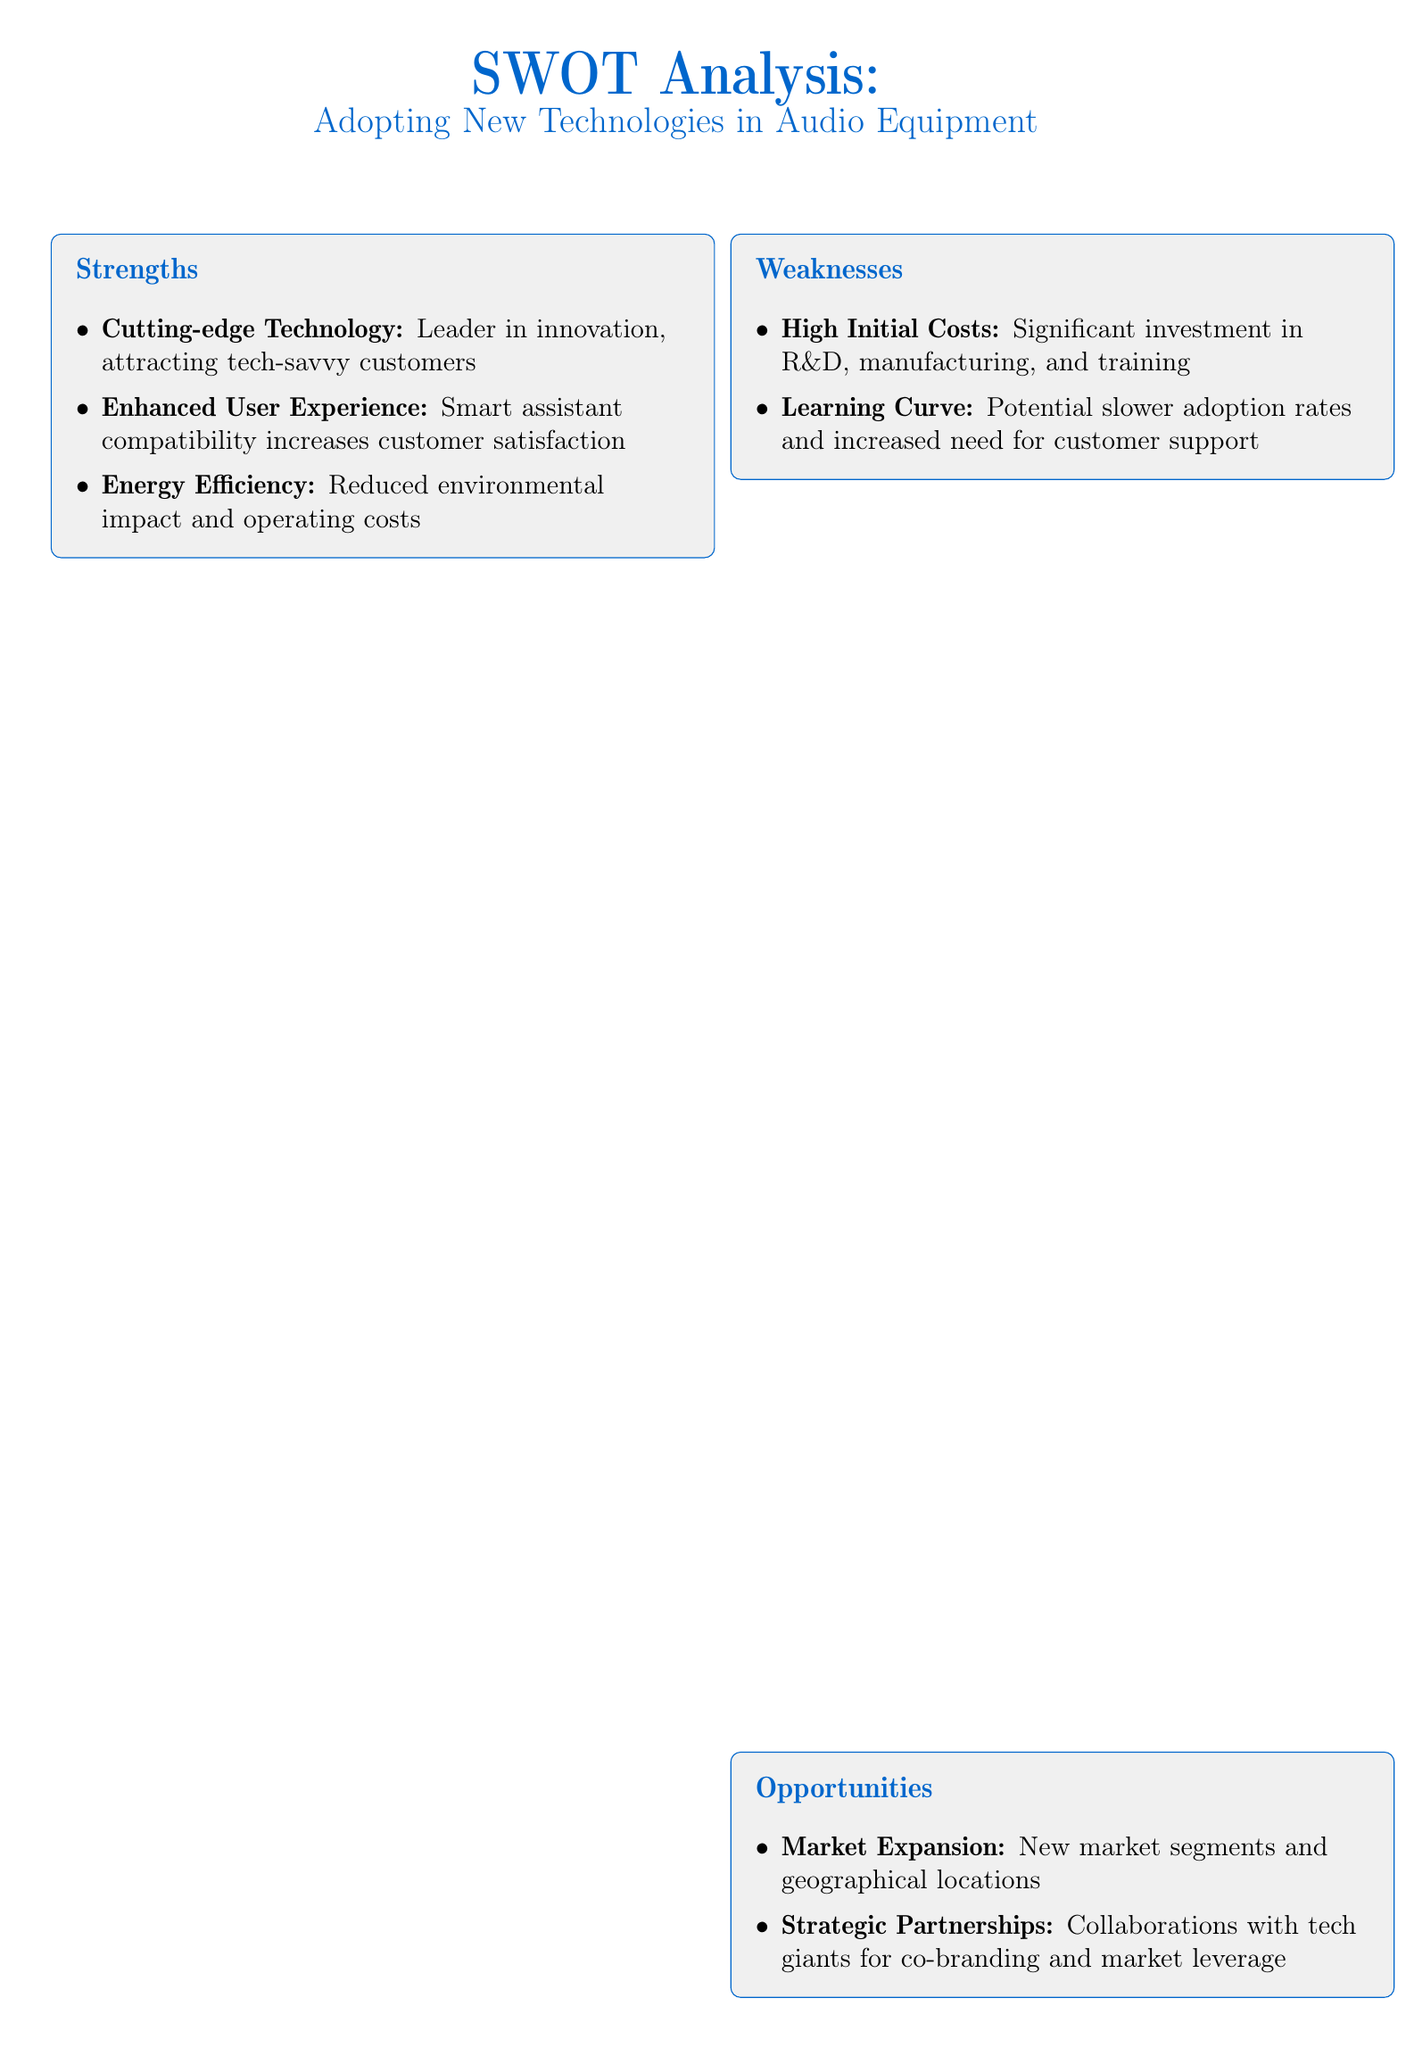What are the strengths of adopting new technologies? The strengths are listed in the document, including cutting-edge technology, enhanced user experience, and energy efficiency.
Answer: Cutting-edge technology, enhanced user experience, energy efficiency What is a weakness associated with adopting new technologies? The weakness section outlines the high initial costs and learning curve associated with new technologies.
Answer: High Initial Costs What opportunities are mentioned for market expansion? The document lists market expansion as an opportunity linked to new market segments and geographical locations.
Answer: New market segments and geographical locations What is a potential threat related to rapid technological changes? The threats section discusses the risk of product obsolescence due to rapid technological changes.
Answer: Risk of product obsolescence What investment is necessary for adopting new technologies? The weaknesses highlight the significant investment required in research, development, and manufacturing.
Answer: Significant investment in R&D What type of partnerships are suggested as an opportunity? The document mentions strategic partnerships with tech giants as a way to enhance market leverage.
Answer: Collaborations with tech giants How does enhanced user experience impact customer satisfaction? The strengths detail that smart assistant compatibility increases customer satisfaction as a part of enhanced user experience.
Answer: Increases customer satisfaction What cybersecurity concern is listed as a threat? The threats section includes the need for robust security measures to protect data as a cybersecurity risk.
Answer: Need for robust security measures Which industry aspect faces competitive pressure? The threats mention challenges from established brands in maintaining market share as a key issue for the industry.
Answer: Maintaining market share What does the conclusion emphasize about adopting new technologies? The conclusion summarizes that adopting new technologies presents significant opportunities but requires careful management of costs and risks.
Answer: Significant opportunities for growth and innovation 